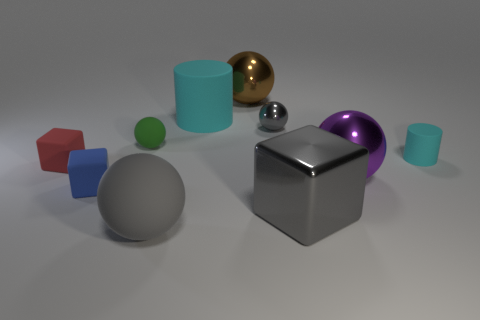Subtract all brown spheres. How many spheres are left? 4 Subtract all small green balls. How many balls are left? 4 Subtract all yellow spheres. Subtract all cyan cubes. How many spheres are left? 5 Subtract all blocks. How many objects are left? 7 Add 1 large cyan objects. How many large cyan objects are left? 2 Add 3 brown matte cylinders. How many brown matte cylinders exist? 3 Subtract 0 yellow cylinders. How many objects are left? 10 Subtract all small rubber balls. Subtract all balls. How many objects are left? 4 